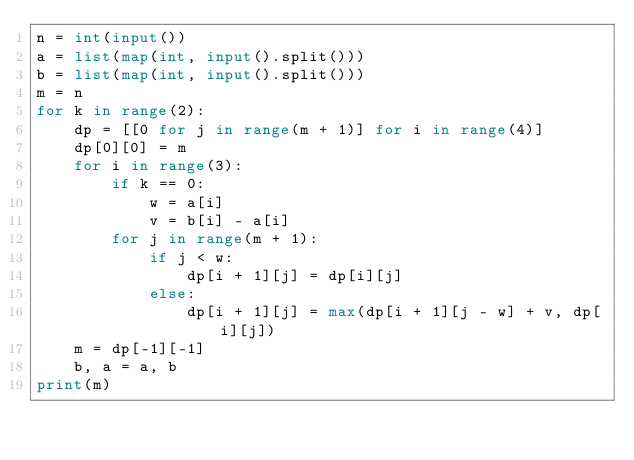<code> <loc_0><loc_0><loc_500><loc_500><_Python_>n = int(input())
a = list(map(int, input().split()))
b = list(map(int, input().split()))
m = n
for k in range(2):
    dp = [[0 for j in range(m + 1)] for i in range(4)]
    dp[0][0] = m
    for i in range(3):
        if k == 0:
            w = a[i]
            v = b[i] - a[i]
        for j in range(m + 1):
            if j < w:
                dp[i + 1][j] = dp[i][j]
            else:
                dp[i + 1][j] = max(dp[i + 1][j - w] + v, dp[i][j])
    m = dp[-1][-1]
    b, a = a, b
print(m)
</code> 